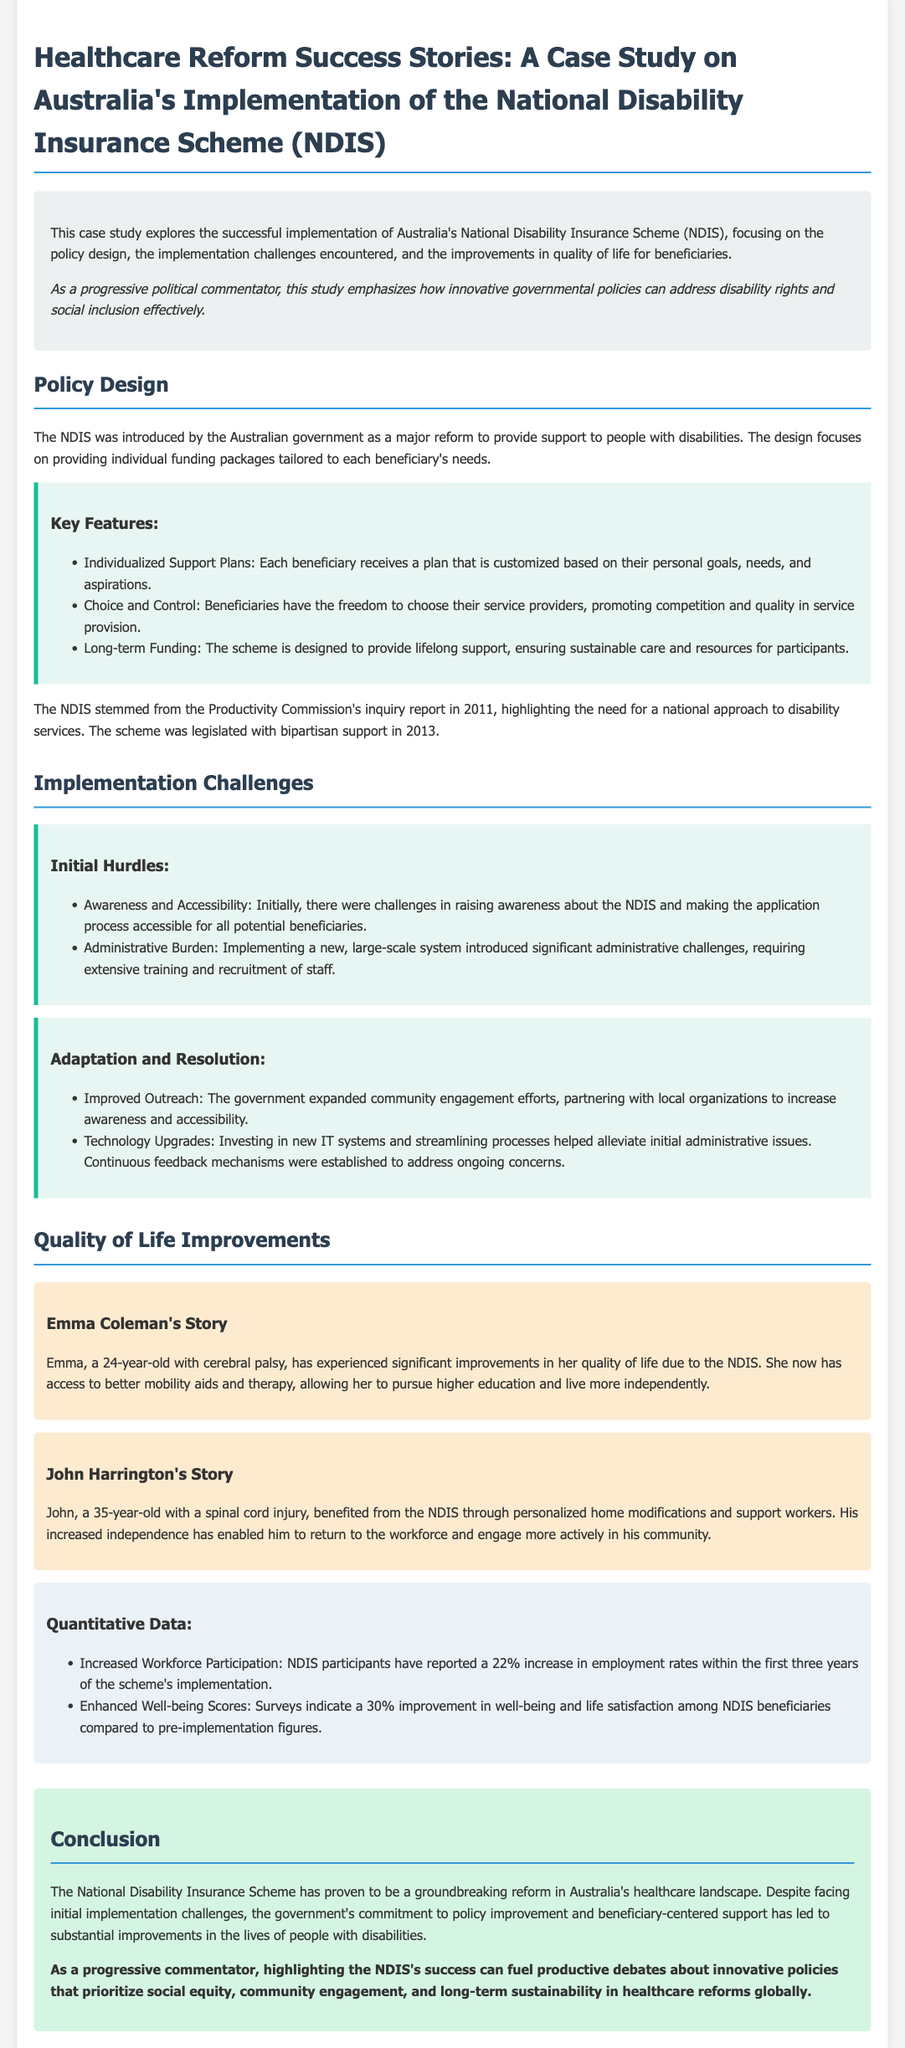What is the main focus of this case study? The main focus of the case study is Australia's implementation of the National Disability Insurance Scheme, including policy design, implementation challenges, and improvements in quality of life for beneficiaries.
Answer: NDIS implementation When was the NDIS legislated? The NDIS was legislated with bipartisan support in 2013.
Answer: 2013 What percentage of increased employment rates is reported among NDIS participants within the first three years? The document states that there is a 22% increase in employment rates among NDIS participants within the first three years of implementation.
Answer: 22% Who is Emma Coleman? Emma Coleman is a 24-year-old with cerebral palsy who has experienced significant improvements in her quality of life due to the NDIS.
Answer: 24-year-old with cerebral palsy What was one of the initial implementation challenges faced by the NDIS? One of the initial challenges faced was raising awareness about the NDIS and making the application process accessible for all potential beneficiaries.
Answer: Awareness and Accessibility What improvements in well-being scores were reported among NDIS beneficiaries? The document indicates there is a 30% improvement in well-being and life satisfaction among NDIS beneficiaries compared to pre-implementation figures.
Answer: 30% What type of support does the NDIS provide? The NDIS provides individualized funding packages tailored to each beneficiary's needs.
Answer: Individualized funding packages What community engagement strategy did the government employ to improve NDIS awareness? The government expanded community engagement efforts by partnering with local organizations to increase awareness and accessibility.
Answer: Local organizations engagement 